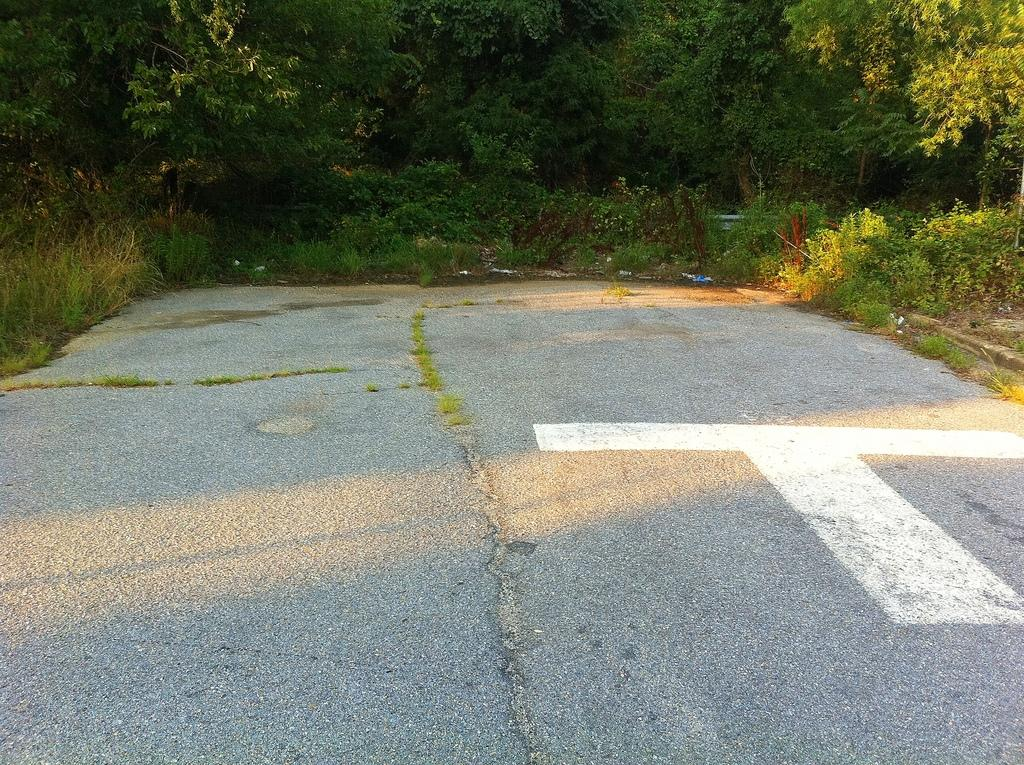What type of vegetation is present in the center of the image? There are trees, grass, and plants in the center of the image. What else can be seen in the center of the image besides vegetation? There is a road in the center of the image. What type of soup is being served in the image? There is no soup present in the image. What toys can be seen in the image? There are no toys present in the image. 